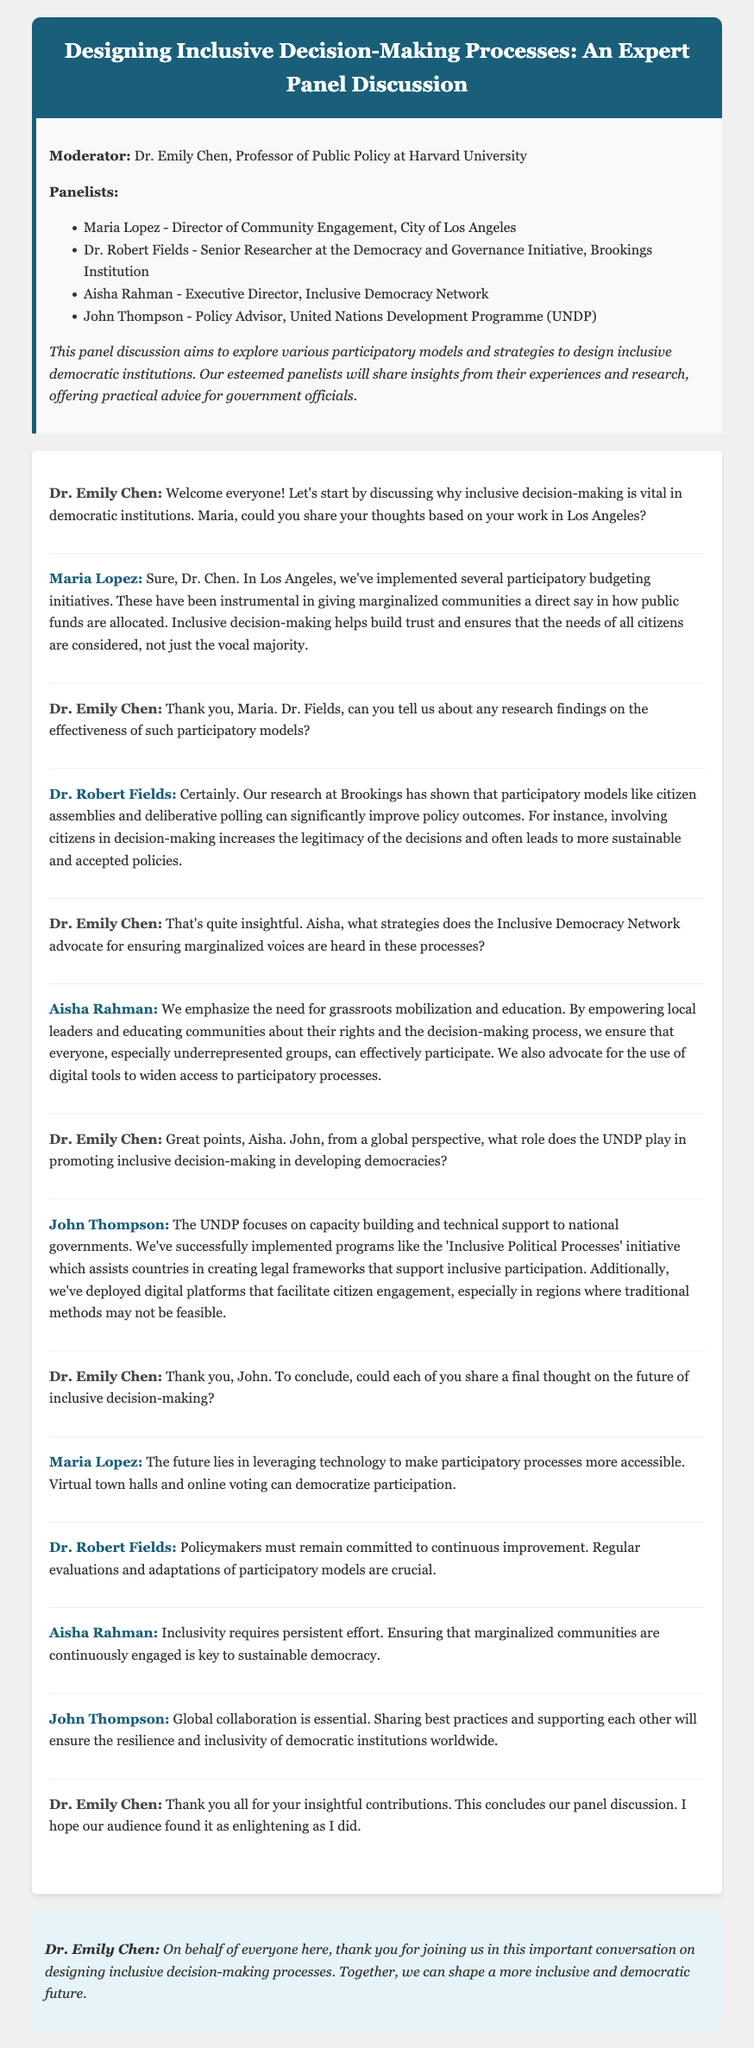What is the title of the panel discussion? The title of the panel discussion is stated in the header of the document.
Answer: Designing Inclusive Decision-Making Processes: Expert Panel Discussion Who is the moderator of the panel? The introduction section specifies the moderator's name and title.
Answer: Dr. Emily Chen What city did Maria Lopez represent? Maria Lopez is introduced as the Director of Community Engagement for the specified city in the panel.
Answer: Los Angeles Which institution is Dr. Robert Fields associated with? Dr. Robert Fields' affiliation is mentioned in the introduction under panelists.
Answer: Brookings Institution What initiative does the UNDP's John Thompson mention? John Thompson refers to a specific initiative in his statement during the discussion.
Answer: Inclusive Political Processes What type of participatory models did Dr. Robert Fields mention has improved policy outcomes? Dr. Fields discusses specific participatory models that have shown effectiveness.
Answer: Citizen assemblies and deliberative polling What is a strategy mentioned by Aisha Rahman for ensuring marginalized voices are heard? Aisha Rahman shares strategies during her response that highlight community empowerment.
Answer: Grassroots mobilization and education What is one future focus Maria Lopez suggests for participatory processes? The future focus Maria Lopez suggests regarding participatory processes is mentioned in her closing remarks.
Answer: Leveraging technology What does John Thompson indicate is essential for the resilience of democratic institutions? John Thompson emphasizes a particular aspect vital for democratic institutions in his final thoughts.
Answer: Global collaboration 